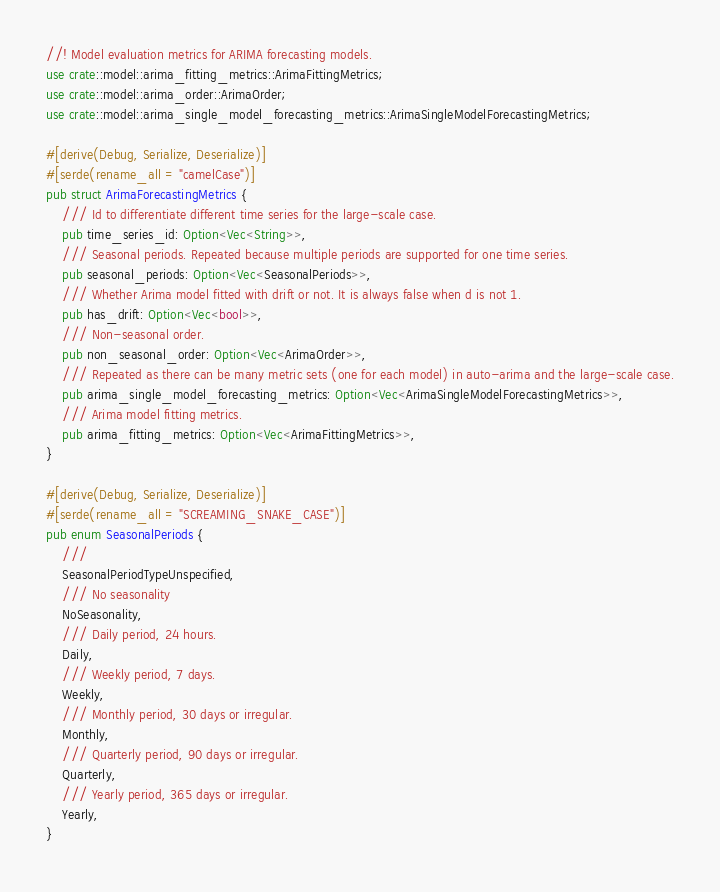<code> <loc_0><loc_0><loc_500><loc_500><_Rust_>//! Model evaluation metrics for ARIMA forecasting models.
use crate::model::arima_fitting_metrics::ArimaFittingMetrics;
use crate::model::arima_order::ArimaOrder;
use crate::model::arima_single_model_forecasting_metrics::ArimaSingleModelForecastingMetrics;

#[derive(Debug, Serialize, Deserialize)]
#[serde(rename_all = "camelCase")]
pub struct ArimaForecastingMetrics {
    /// Id to differentiate different time series for the large-scale case.
    pub time_series_id: Option<Vec<String>>,
    /// Seasonal periods. Repeated because multiple periods are supported for one time series.
    pub seasonal_periods: Option<Vec<SeasonalPeriods>>,
    /// Whether Arima model fitted with drift or not. It is always false when d is not 1.
    pub has_drift: Option<Vec<bool>>,
    /// Non-seasonal order.
    pub non_seasonal_order: Option<Vec<ArimaOrder>>,
    /// Repeated as there can be many metric sets (one for each model) in auto-arima and the large-scale case.
    pub arima_single_model_forecasting_metrics: Option<Vec<ArimaSingleModelForecastingMetrics>>,
    /// Arima model fitting metrics.
    pub arima_fitting_metrics: Option<Vec<ArimaFittingMetrics>>,
}

#[derive(Debug, Serialize, Deserialize)]
#[serde(rename_all = "SCREAMING_SNAKE_CASE")]
pub enum SeasonalPeriods {
    ///
    SeasonalPeriodTypeUnspecified,
    /// No seasonality
    NoSeasonality,
    /// Daily period, 24 hours.
    Daily,
    /// Weekly period, 7 days.
    Weekly,
    /// Monthly period, 30 days or irregular.
    Monthly,
    /// Quarterly period, 90 days or irregular.
    Quarterly,
    /// Yearly period, 365 days or irregular.
    Yearly,
}
</code> 